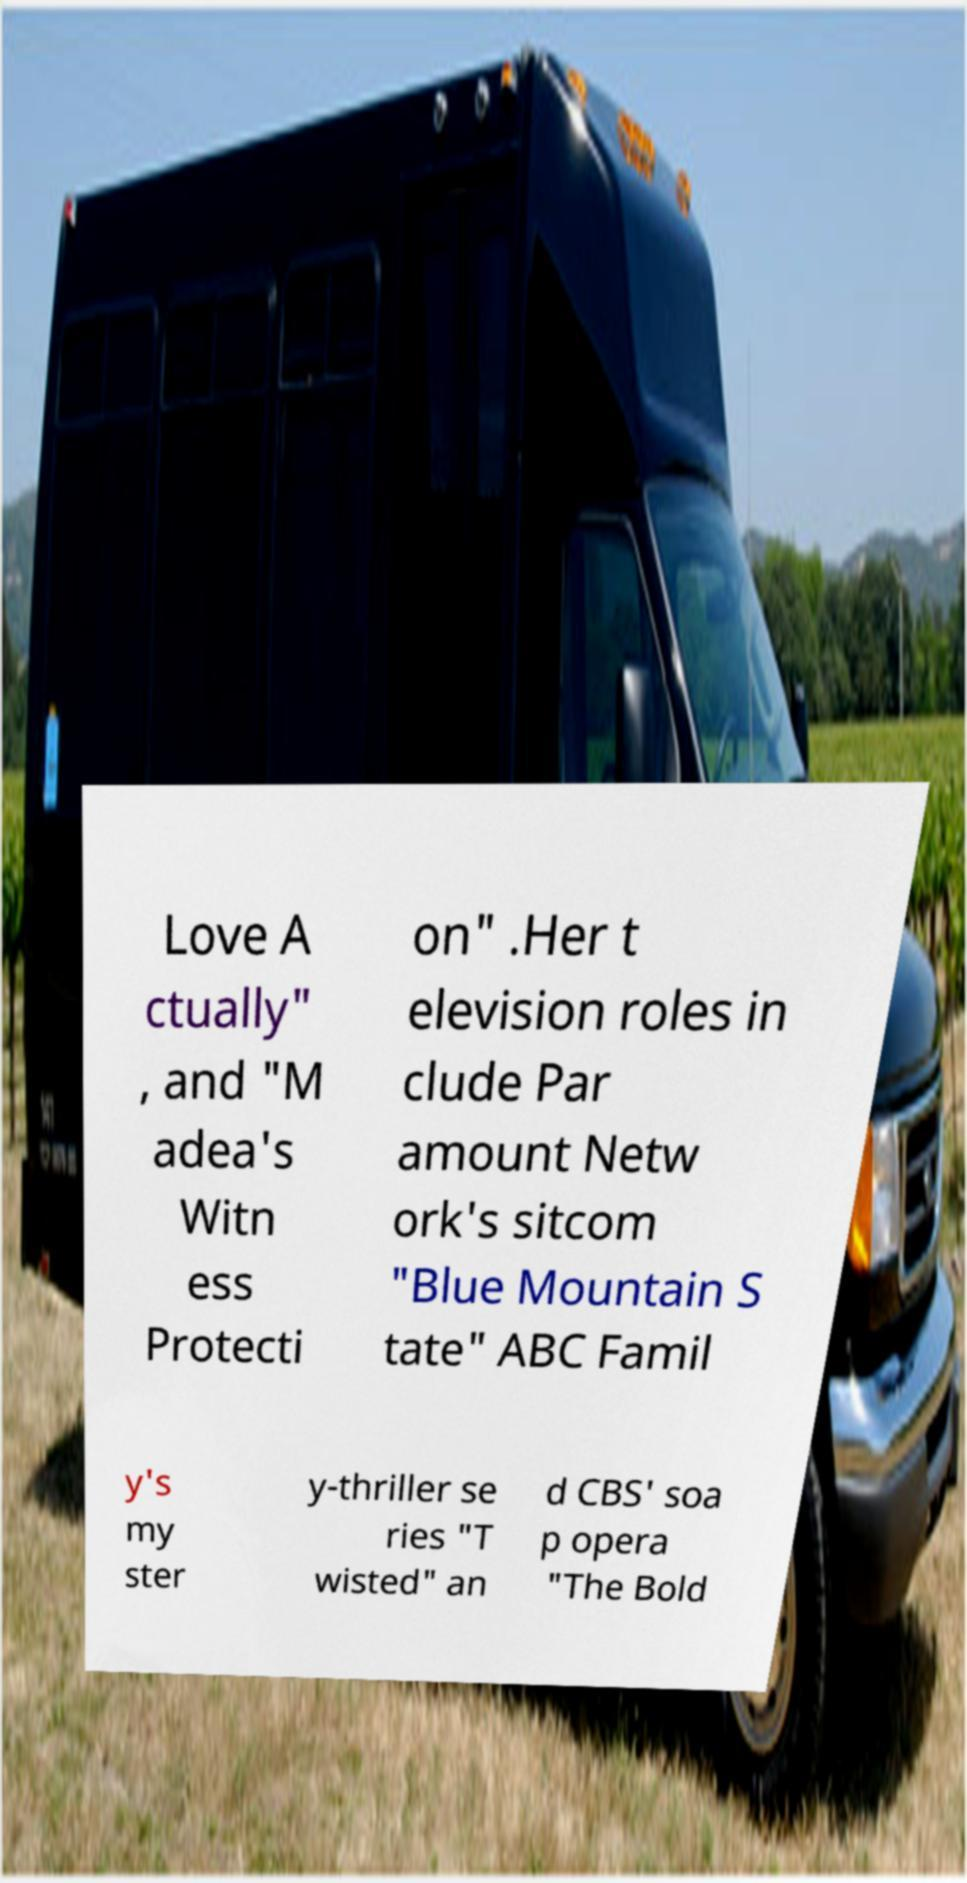There's text embedded in this image that I need extracted. Can you transcribe it verbatim? Love A ctually" , and "M adea's Witn ess Protecti on" .Her t elevision roles in clude Par amount Netw ork's sitcom "Blue Mountain S tate" ABC Famil y's my ster y-thriller se ries "T wisted" an d CBS' soa p opera "The Bold 